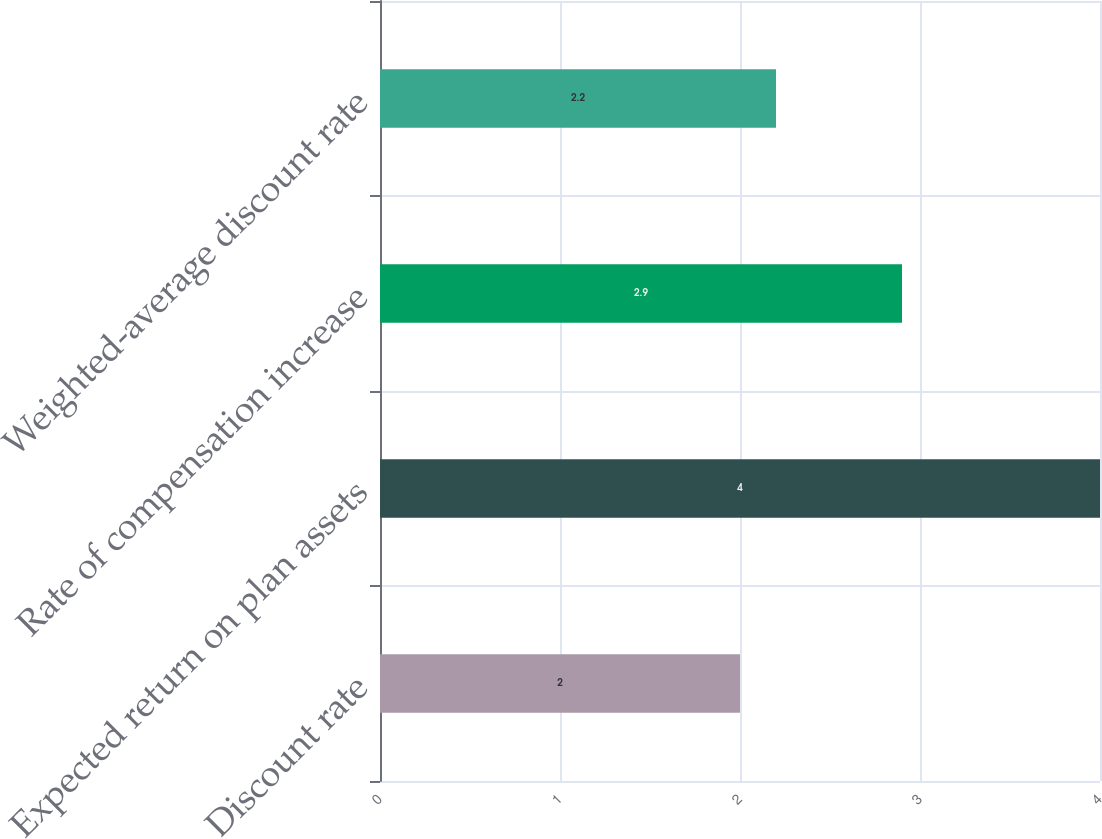<chart> <loc_0><loc_0><loc_500><loc_500><bar_chart><fcel>Discount rate<fcel>Expected return on plan assets<fcel>Rate of compensation increase<fcel>Weighted-average discount rate<nl><fcel>2<fcel>4<fcel>2.9<fcel>2.2<nl></chart> 